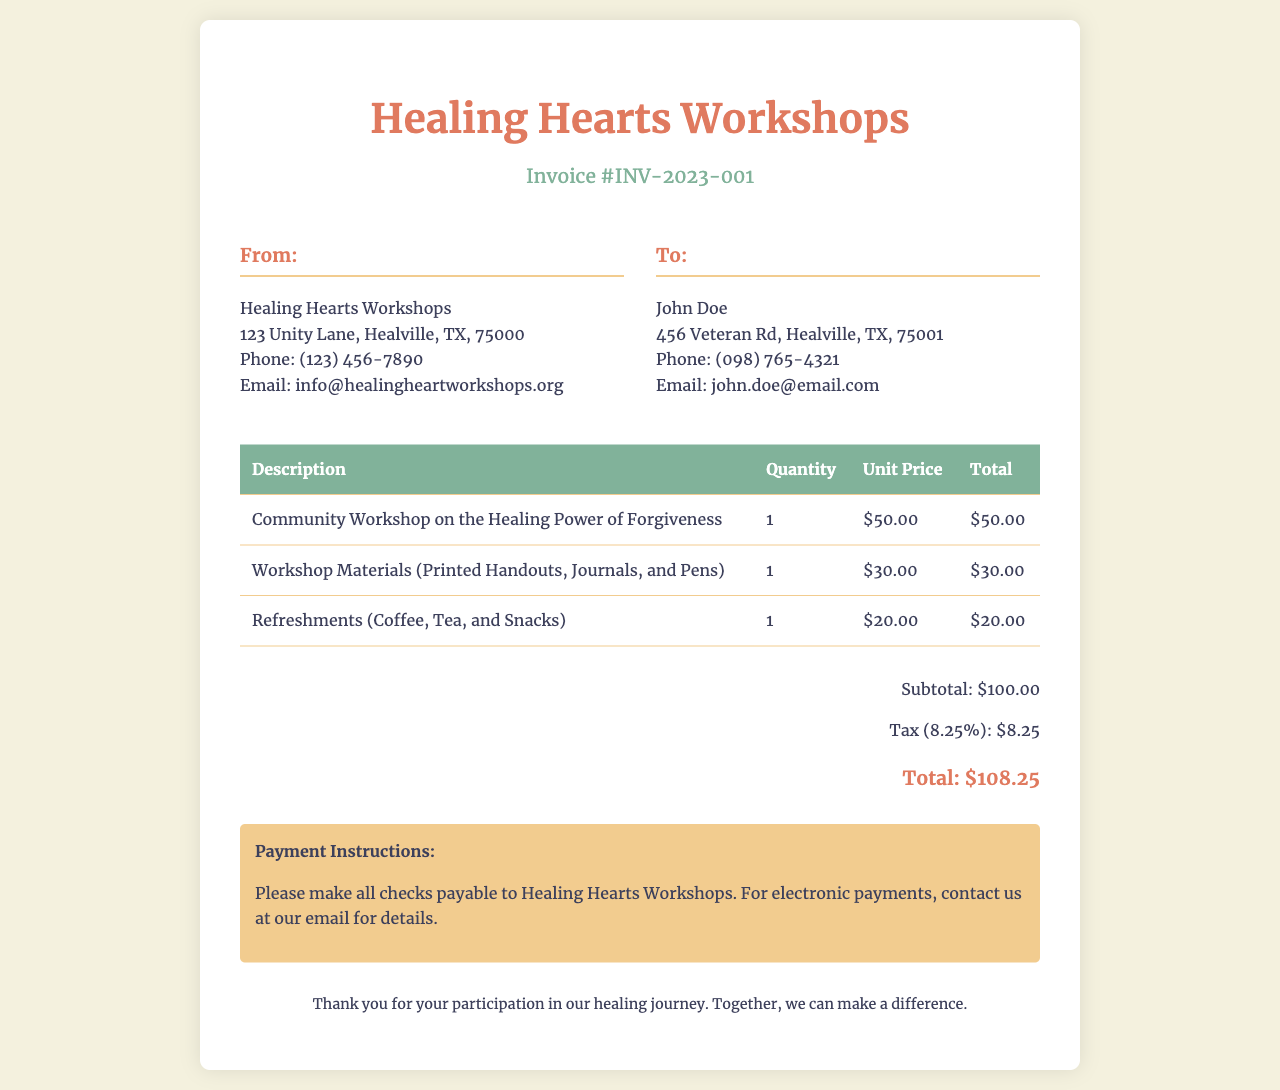What is the invoice number? The invoice number is specifically listed in the document as INV-2023-001.
Answer: INV-2023-001 What is the cost of workshop materials? The cost of workshop materials, which includes printed handouts, journals, and pens, is detailed as $30.00.
Answer: $30.00 Who is the invoice addressed to? The invoice shows the recipient's name as John Doe.
Answer: John Doe What is the total amount due? The total amount due is calculated at the bottom of the invoice as $108.25.
Answer: $108.25 What is included in the refreshments? The invoice mentions that refreshments consist of coffee, tea, and snacks.
Answer: Coffee, Tea, and Snacks How much tax is applied? The tax amount is explicitly stated as 8.25%, which amounts to $8.25.
Answer: $8.25 What is the subtotal before tax? The subtotal before tax is indicated in the document as $100.00.
Answer: $100.00 Where should payment checks be made out to? The payment instructions specify that checks should be made payable to Healing Hearts Workshops.
Answer: Healing Hearts Workshops What is the phone number of Healing Hearts Workshops? The contact number for Healing Hearts Workshops provided in the document is (123) 456-7890.
Answer: (123) 456-7890 